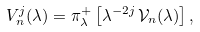Convert formula to latex. <formula><loc_0><loc_0><loc_500><loc_500>V _ { n } ^ { j } ( \lambda ) = \pi _ { \lambda } ^ { + } \left [ \lambda ^ { - 2 j } \, \mathcal { V } _ { n } ( \lambda ) \right ] ,</formula> 